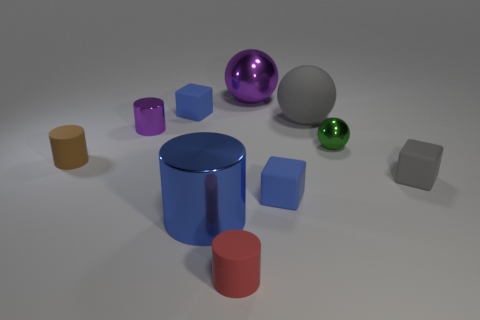Subtract all blocks. How many objects are left? 7 Subtract 1 red cylinders. How many objects are left? 9 Subtract all big blue cylinders. Subtract all small blue things. How many objects are left? 7 Add 5 big shiny cylinders. How many big shiny cylinders are left? 6 Add 1 purple metallic balls. How many purple metallic balls exist? 2 